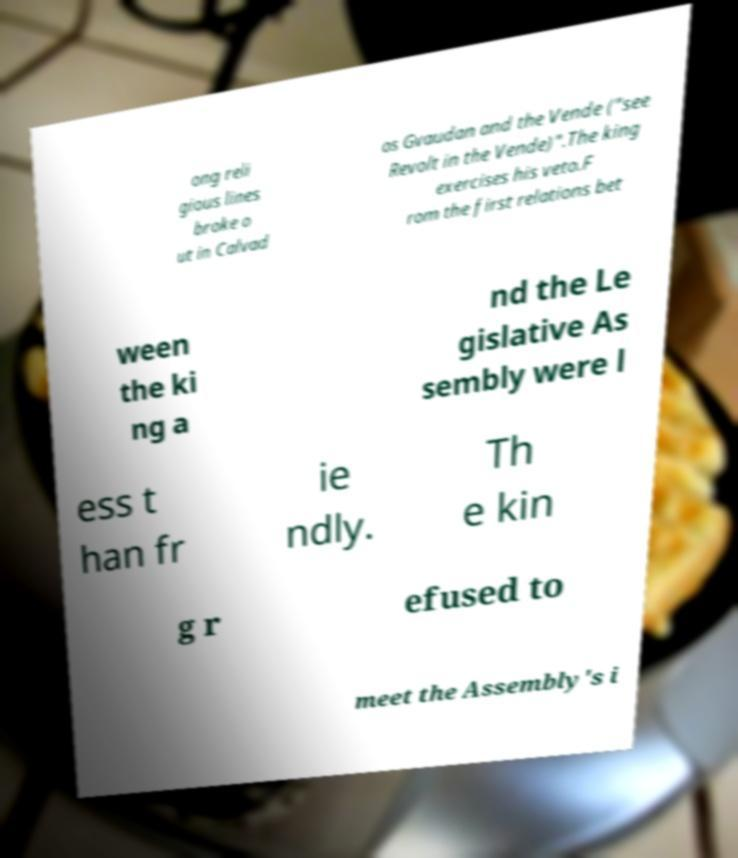There's text embedded in this image that I need extracted. Can you transcribe it verbatim? ong reli gious lines broke o ut in Calvad os Gvaudan and the Vende ("see Revolt in the Vende)".The king exercises his veto.F rom the first relations bet ween the ki ng a nd the Le gislative As sembly were l ess t han fr ie ndly. Th e kin g r efused to meet the Assembly's i 